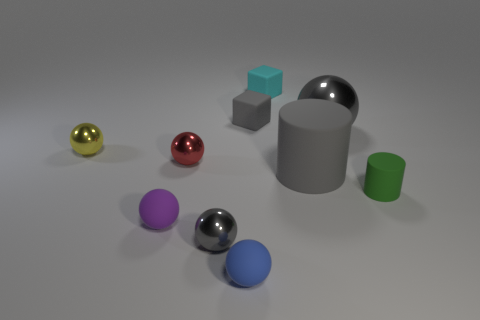The rubber object that is on the left side of the tiny blue matte object is what color?
Your answer should be very brief. Purple. There is a green matte cylinder that is right of the tiny blue object; is there a purple thing that is behind it?
Keep it short and to the point. No. Is the color of the large object that is behind the small yellow ball the same as the matte sphere that is in front of the small purple thing?
Your answer should be very brief. No. There is a blue matte object; how many gray cylinders are left of it?
Give a very brief answer. 0. How many small metallic things are the same color as the large matte object?
Give a very brief answer. 1. Are the tiny cube behind the small gray matte thing and the purple thing made of the same material?
Offer a terse response. Yes. What number of other small things have the same material as the tiny yellow object?
Your answer should be very brief. 2. Are there more small matte blocks right of the big gray matte thing than green cylinders?
Your answer should be very brief. No. The block that is the same color as the big rubber object is what size?
Offer a very short reply. Small. Are there any green things that have the same shape as the small blue thing?
Offer a terse response. No. 